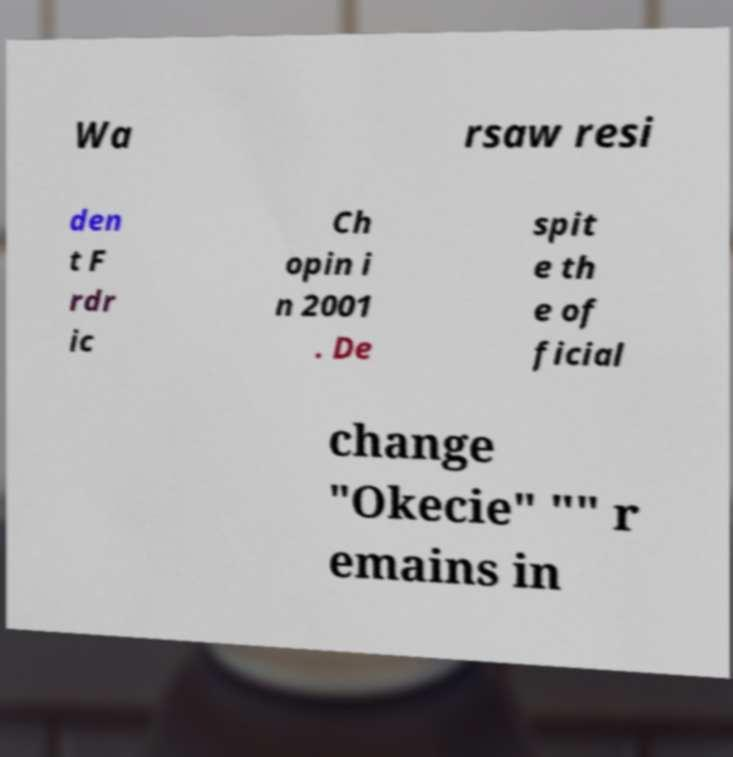Can you accurately transcribe the text from the provided image for me? Wa rsaw resi den t F rdr ic Ch opin i n 2001 . De spit e th e of ficial change "Okecie" "" r emains in 